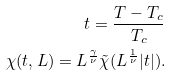Convert formula to latex. <formula><loc_0><loc_0><loc_500><loc_500>t = \frac { T - T _ { c } } { T _ { c } } \\ \chi ( t , L ) = L ^ { \frac { \gamma } { \nu } } \tilde { \chi } ( L ^ { \frac { 1 } { \nu } } | t | ) .</formula> 